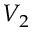Convert formula to latex. <formula><loc_0><loc_0><loc_500><loc_500>V _ { 2 }</formula> 